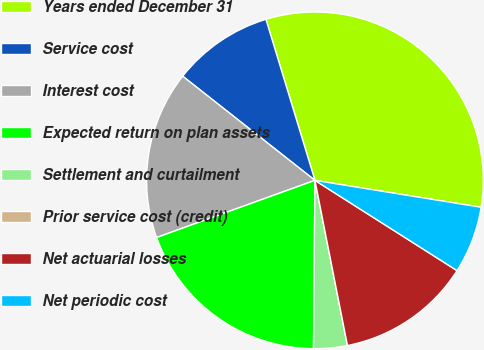<chart> <loc_0><loc_0><loc_500><loc_500><pie_chart><fcel>Years ended December 31<fcel>Service cost<fcel>Interest cost<fcel>Expected return on plan assets<fcel>Settlement and curtailment<fcel>Prior service cost (credit)<fcel>Net actuarial losses<fcel>Net periodic cost<nl><fcel>32.26%<fcel>9.68%<fcel>16.13%<fcel>19.35%<fcel>3.23%<fcel>0.0%<fcel>12.9%<fcel>6.45%<nl></chart> 